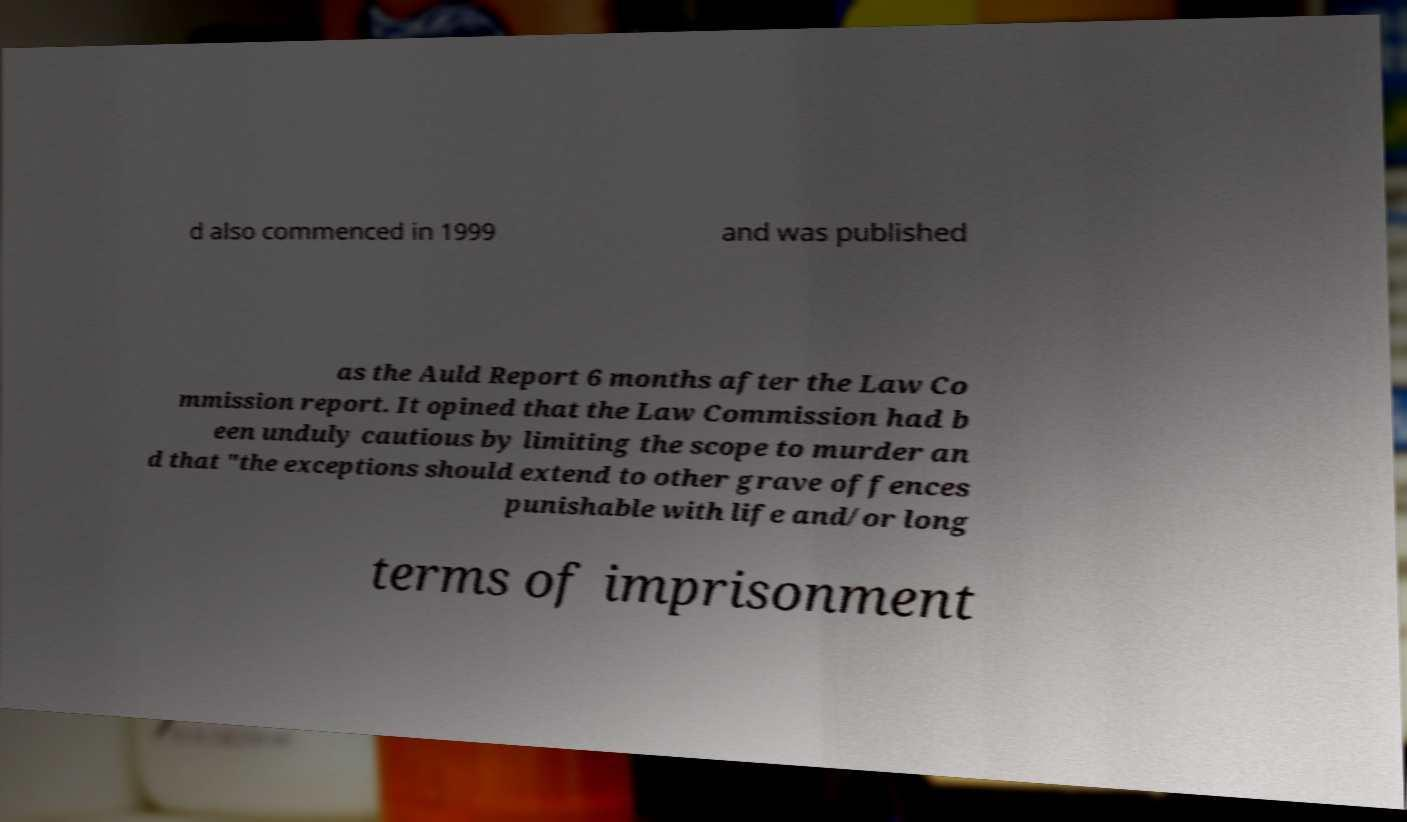For documentation purposes, I need the text within this image transcribed. Could you provide that? d also commenced in 1999 and was published as the Auld Report 6 months after the Law Co mmission report. It opined that the Law Commission had b een unduly cautious by limiting the scope to murder an d that "the exceptions should extend to other grave offences punishable with life and/or long terms of imprisonment 